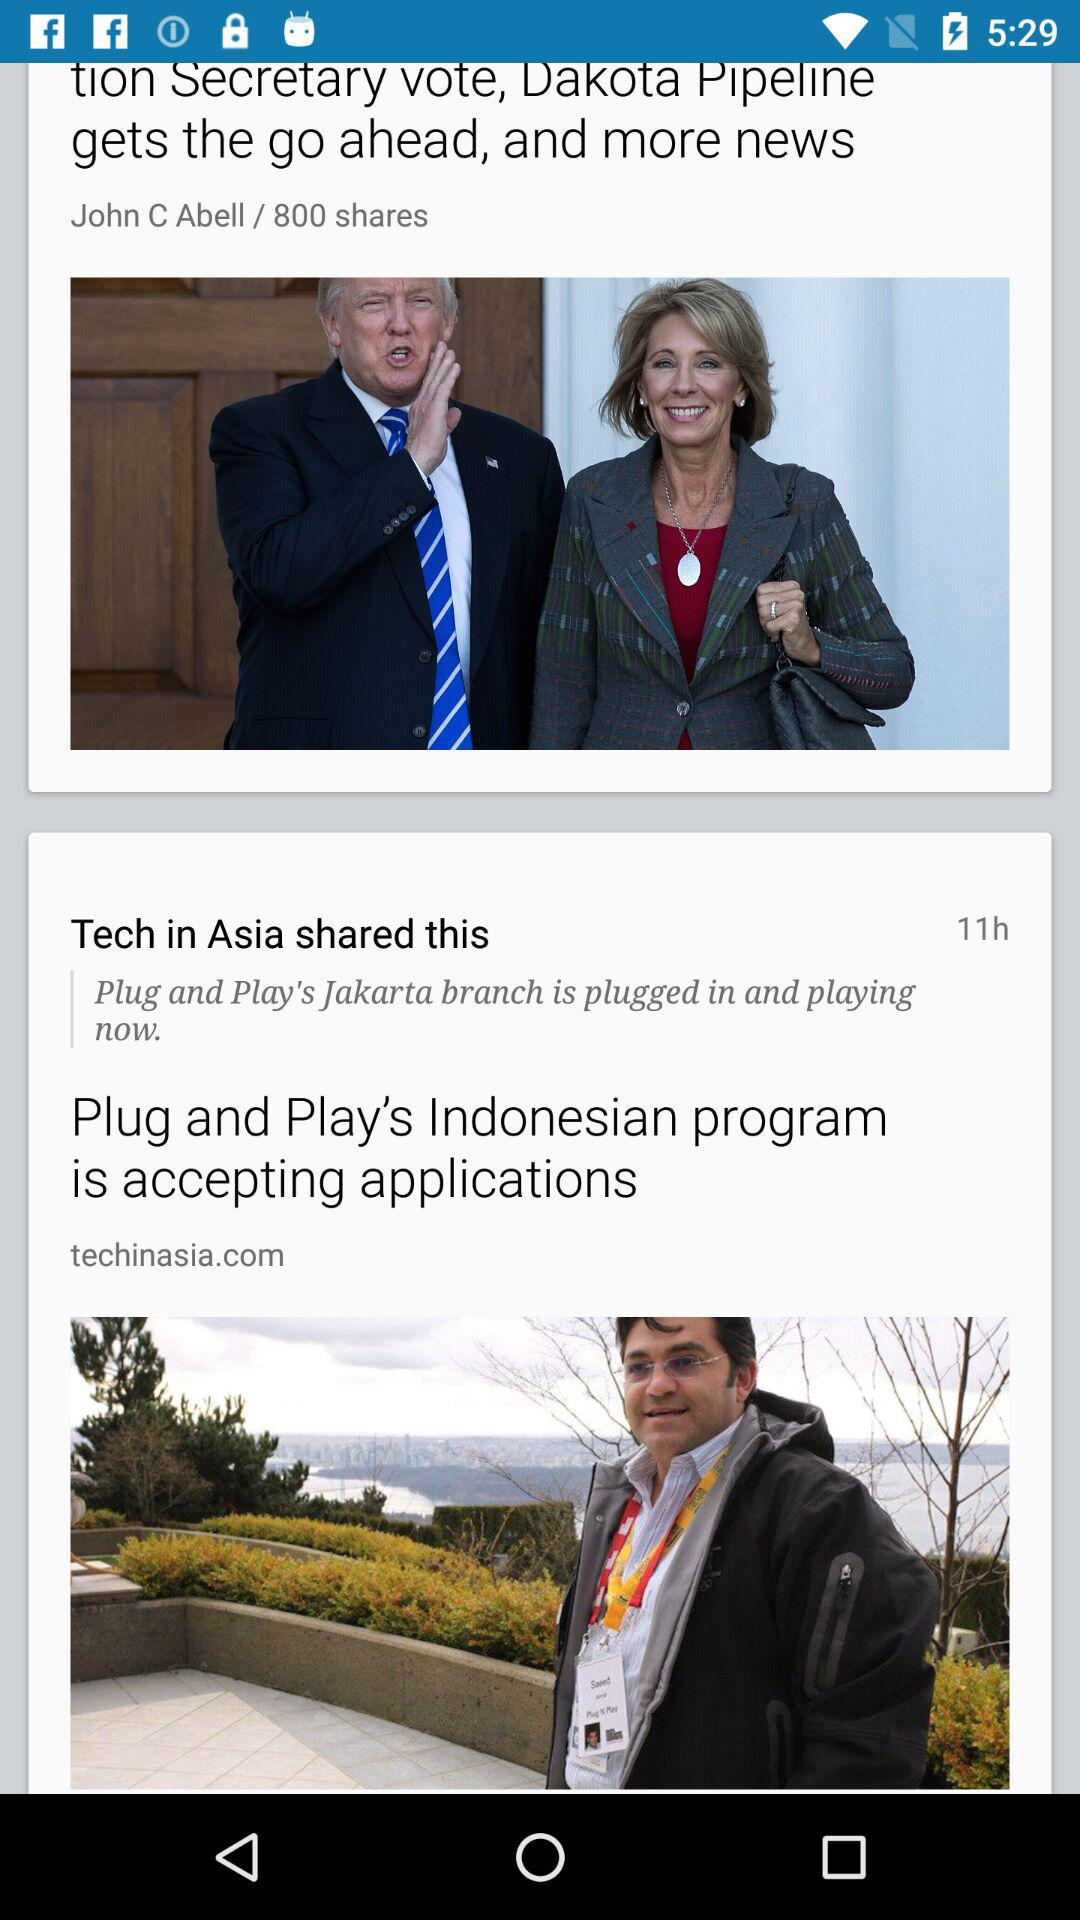When did "Tech in Asia" share the post? "Tech in Asia" shared the post 11 hours ago. 